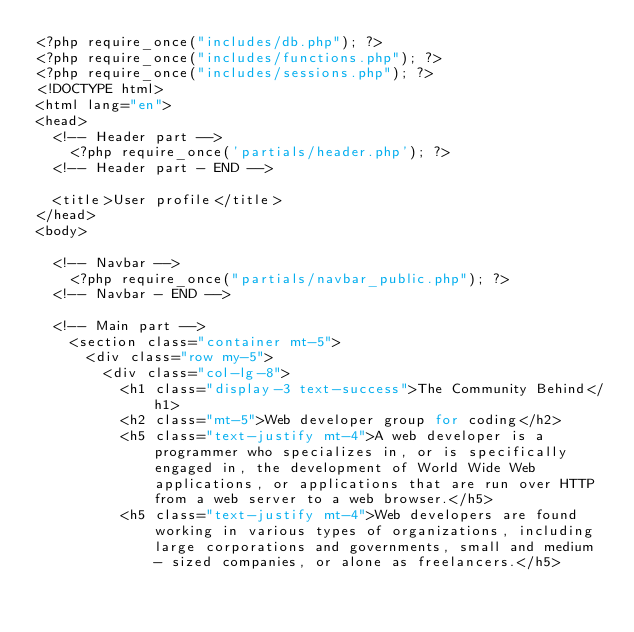<code> <loc_0><loc_0><loc_500><loc_500><_PHP_><?php require_once("includes/db.php"); ?>
<?php require_once("includes/functions.php"); ?>
<?php require_once("includes/sessions.php"); ?>
<!DOCTYPE html>
<html lang="en">
<head>
  <!-- Header part -->
    <?php require_once('partials/header.php'); ?>
  <!-- Header part - END -->

  <title>User profile</title>
</head>
<body>

  <!-- Navbar -->
    <?php require_once("partials/navbar_public.php"); ?>
  <!-- Navbar - END -->

  <!-- Main part -->
    <section class="container mt-5">
      <div class="row my-5">
        <div class="col-lg-8">
          <h1 class="display-3 text-success">The Community Behind</h1>
          <h2 class="mt-5">Web developer group for coding</h2>
          <h5 class="text-justify mt-4">A web developer is a programmer who specializes in, or is specifically engaged in, the development of World Wide Web applications, or applications that are run over HTTP from a web server to a web browser.</h5>
          <h5 class="text-justify mt-4">Web developers are found working in various types of organizations, including large corporations and governments, small and medium - sized companies, or alone as freelancers.</h5></code> 